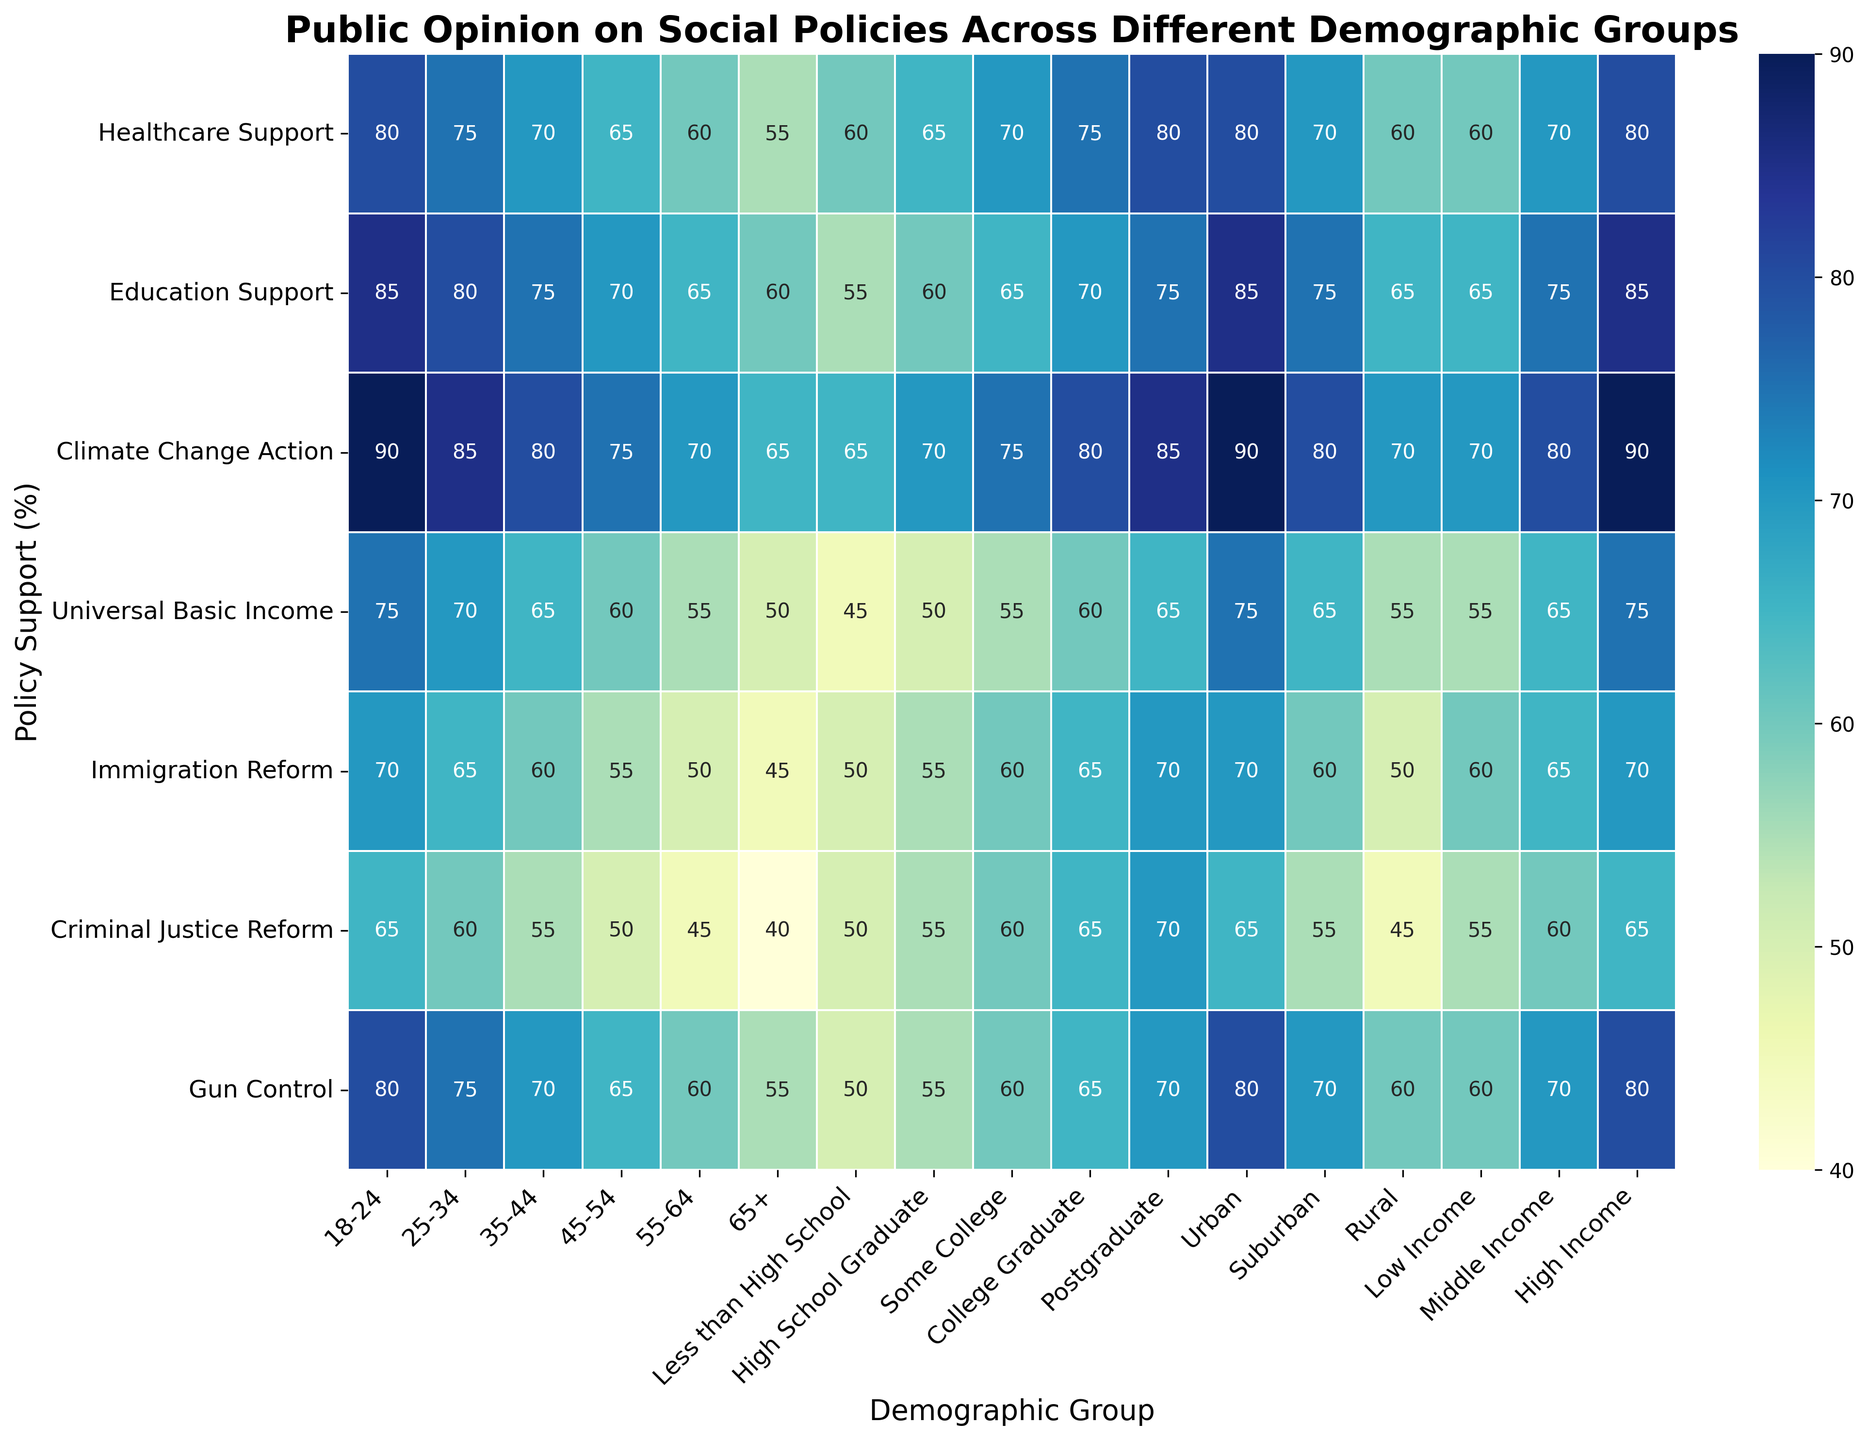How does support for Criminal Justice Reform compare across the different age groups? To find this, look at the row for "Criminal Justice Reform" and compare the percentages across the age groups (18-24, 25-34, 35-44, 45-54, 55-64, 65+). We see values of 65, 60, 55, 50, 45, and 40, respectively.
Answer: Support decreases as age increases, highest in 18-24 at 65% and lowest in 65+ at 40% In which demographic group do we see the highest support for Education Support? Look at the "Education Support" row and find the highest value. The values are 85, 80, 75, 70, 65, 60, 55, 60, 65, 70, 75, 85, 75, 65, 65, 75, 85. The highest value is 85.
Answer: 18-24, Urban, High Income groups (all 85%) What is the average support for Universal Basic Income across income groups? To calculate the average, sum the values in the "Universal Basic Income" row for the three income groups (55, 65, 75) and then divide by the number of groups. Calculation: (55 + 65 + 75) / 3 = 65
Answer: 65 Which demographic group shows the least support for Gun Control? Look at the "Gun Control" row and find the lowest value. The values are 80, 75, 70, 65, 60, 55, 50, 55, 60, 65, 70, 80, 70, 60, 60, 70, 80. The lowest value is 50.
Answer: Less than High School group (50%) How much higher is support for Climate Change Action in urban areas compared to rural areas? Look at the "Climate Change Action" row and subtract the value for rural areas (70) from the value for urban areas (90). Calculation: 90 - 70 = 20
Answer: 20 Which group has higher support for Immigration Reform, 25-34 or 35-44 age group? Compare the values in the "Immigration Reform" row for the 25-34 group (65) and the 35-44 group (60).
Answer: 25-34 age group How does support for Healthcare Support change from the youngest to the oldest age group? Compare the values in the "Healthcare Support" row for the 18-24 group (80) and the 65+ group (55).
Answer: Support decreases from 80% in 18-24 to 55% in 65+ What is the range of support values for Climate Change Action across educational levels? To find the range, subtract the smallest value from the largest value in the "Climate Change Action" row for educational levels (45, 50, 55, 60, 65). Largest value: 65. Smallest value: 45. Calculation: 65 - 45 = 20
Answer: 20 In which demographic group do we see the closest support percentages for Healthcare Support and Immigration Reform? Look for the row "Healthcare Support" and "Immigration Reform" and compare values across demographic groups to find the closest pairs: 18-24 (80, 65), 25-34 (75, 60), 35-44 (70, 55), 45-54 (65, 50), 55-64 (60, 45), 65+ (55, 40), Less than High School (60, 50), High School Graduate (65, 55), Some College (70, 60), College Graduate (75, 65), Postgraduate (80, 70), Urban (80, 70), Suburban (70, 60), Rural (60, 50), Low Income (60, 55), Middle Income (70, 65), High Income (80, 70). The closest pairs are within 5% in several groups such as Less than High School, Some College, and others.
Answer: Multiple groups with close values (e.g., Some College, High School Graduate, etc.) 